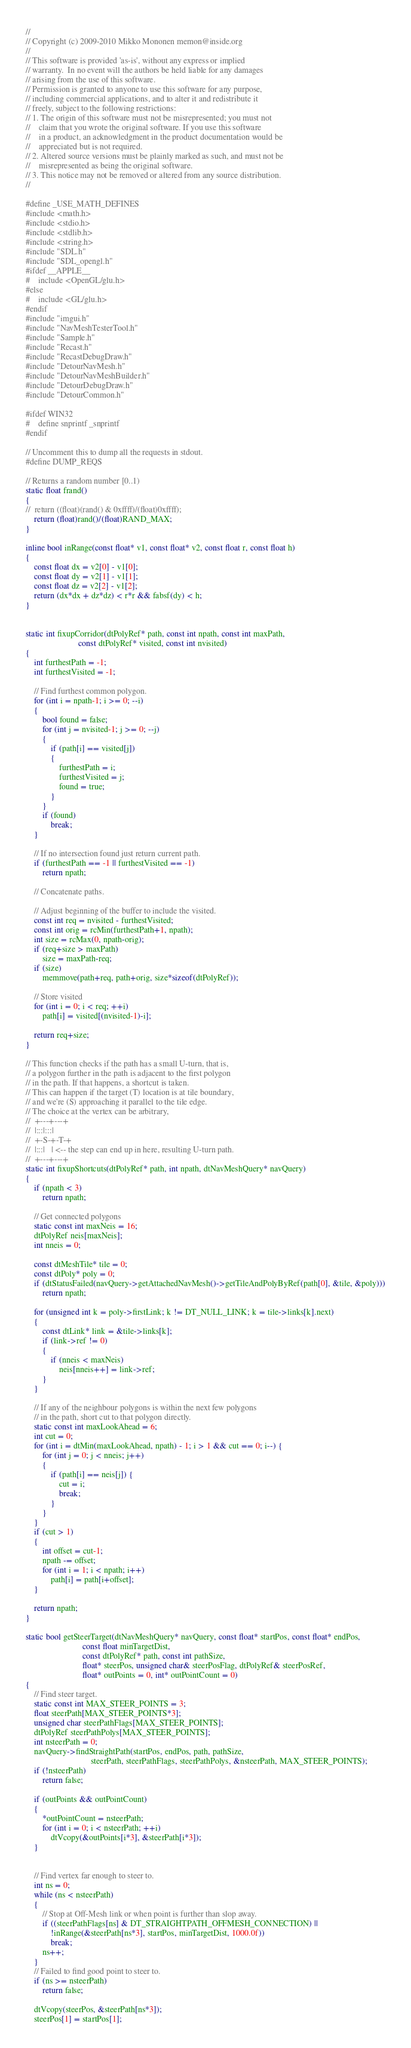Convert code to text. <code><loc_0><loc_0><loc_500><loc_500><_C++_>//
// Copyright (c) 2009-2010 Mikko Mononen memon@inside.org
//
// This software is provided 'as-is', without any express or implied
// warranty.  In no event will the authors be held liable for any damages
// arising from the use of this software.
// Permission is granted to anyone to use this software for any purpose,
// including commercial applications, and to alter it and redistribute it
// freely, subject to the following restrictions:
// 1. The origin of this software must not be misrepresented; you must not
//    claim that you wrote the original software. If you use this software
//    in a product, an acknowledgment in the product documentation would be
//    appreciated but is not required.
// 2. Altered source versions must be plainly marked as such, and must not be
//    misrepresented as being the original software.
// 3. This notice may not be removed or altered from any source distribution.
//

#define _USE_MATH_DEFINES
#include <math.h>
#include <stdio.h>
#include <stdlib.h>
#include <string.h>
#include "SDL.h"
#include "SDL_opengl.h"
#ifdef __APPLE__
#	include <OpenGL/glu.h>
#else
#	include <GL/glu.h>
#endif
#include "imgui.h"
#include "NavMeshTesterTool.h"
#include "Sample.h"
#include "Recast.h"
#include "RecastDebugDraw.h"
#include "DetourNavMesh.h"
#include "DetourNavMeshBuilder.h"
#include "DetourDebugDraw.h"
#include "DetourCommon.h"

#ifdef WIN32
#	define snprintf _snprintf
#endif

// Uncomment this to dump all the requests in stdout.
#define DUMP_REQS

// Returns a random number [0..1)
static float frand()
{
//	return ((float)(rand() & 0xffff)/(float)0xffff);
	return (float)rand()/(float)RAND_MAX;
}

inline bool inRange(const float* v1, const float* v2, const float r, const float h)
{
	const float dx = v2[0] - v1[0];
	const float dy = v2[1] - v1[1];
	const float dz = v2[2] - v1[2];
	return (dx*dx + dz*dz) < r*r && fabsf(dy) < h;
}


static int fixupCorridor(dtPolyRef* path, const int npath, const int maxPath,
						 const dtPolyRef* visited, const int nvisited)
{
	int furthestPath = -1;
	int furthestVisited = -1;
	
	// Find furthest common polygon.
	for (int i = npath-1; i >= 0; --i)
	{
		bool found = false;
		for (int j = nvisited-1; j >= 0; --j)
		{
			if (path[i] == visited[j])
			{
				furthestPath = i;
				furthestVisited = j;
				found = true;
			}
		}
		if (found)
			break;
	}

	// If no intersection found just return current path. 
	if (furthestPath == -1 || furthestVisited == -1)
		return npath;
	
	// Concatenate paths.	

	// Adjust beginning of the buffer to include the visited.
	const int req = nvisited - furthestVisited;
	const int orig = rcMin(furthestPath+1, npath);
	int size = rcMax(0, npath-orig);
	if (req+size > maxPath)
		size = maxPath-req;
	if (size)
		memmove(path+req, path+orig, size*sizeof(dtPolyRef));
	
	// Store visited
	for (int i = 0; i < req; ++i)
		path[i] = visited[(nvisited-1)-i];				
	
	return req+size;
}

// This function checks if the path has a small U-turn, that is,
// a polygon further in the path is adjacent to the first polygon
// in the path. If that happens, a shortcut is taken.
// This can happen if the target (T) location is at tile boundary,
// and we're (S) approaching it parallel to the tile edge.
// The choice at the vertex can be arbitrary, 
//  +---+---+
//  |:::|:::|
//  +-S-+-T-+
//  |:::|   | <-- the step can end up in here, resulting U-turn path.
//  +---+---+
static int fixupShortcuts(dtPolyRef* path, int npath, dtNavMeshQuery* navQuery)
{
	if (npath < 3)
		return npath;

	// Get connected polygons
	static const int maxNeis = 16;
	dtPolyRef neis[maxNeis];
	int nneis = 0;

	const dtMeshTile* tile = 0;
	const dtPoly* poly = 0;
	if (dtStatusFailed(navQuery->getAttachedNavMesh()->getTileAndPolyByRef(path[0], &tile, &poly)))
		return npath;
	
	for (unsigned int k = poly->firstLink; k != DT_NULL_LINK; k = tile->links[k].next)
	{
		const dtLink* link = &tile->links[k];
		if (link->ref != 0)
		{
			if (nneis < maxNeis)
				neis[nneis++] = link->ref;
		}
	}

	// If any of the neighbour polygons is within the next few polygons
	// in the path, short cut to that polygon directly.
	static const int maxLookAhead = 6;
	int cut = 0;
	for (int i = dtMin(maxLookAhead, npath) - 1; i > 1 && cut == 0; i--) {
		for (int j = 0; j < nneis; j++)
		{
			if (path[i] == neis[j]) {
				cut = i;
				break;
			}
		}
	}
	if (cut > 1)
	{
		int offset = cut-1;
		npath -= offset;
		for (int i = 1; i < npath; i++)
			path[i] = path[i+offset];
	}

	return npath;
}

static bool getSteerTarget(dtNavMeshQuery* navQuery, const float* startPos, const float* endPos,
						   const float minTargetDist,
						   const dtPolyRef* path, const int pathSize,
						   float* steerPos, unsigned char& steerPosFlag, dtPolyRef& steerPosRef,
						   float* outPoints = 0, int* outPointCount = 0)							 
{
	// Find steer target.
	static const int MAX_STEER_POINTS = 3;
	float steerPath[MAX_STEER_POINTS*3];
	unsigned char steerPathFlags[MAX_STEER_POINTS];
	dtPolyRef steerPathPolys[MAX_STEER_POINTS];
	int nsteerPath = 0;
	navQuery->findStraightPath(startPos, endPos, path, pathSize,
							   steerPath, steerPathFlags, steerPathPolys, &nsteerPath, MAX_STEER_POINTS);
	if (!nsteerPath)
		return false;
		
	if (outPoints && outPointCount)
	{
		*outPointCount = nsteerPath;
		for (int i = 0; i < nsteerPath; ++i)
			dtVcopy(&outPoints[i*3], &steerPath[i*3]);
	}

	
	// Find vertex far enough to steer to.
	int ns = 0;
	while (ns < nsteerPath)
	{
		// Stop at Off-Mesh link or when point is further than slop away.
		if ((steerPathFlags[ns] & DT_STRAIGHTPATH_OFFMESH_CONNECTION) ||
			!inRange(&steerPath[ns*3], startPos, minTargetDist, 1000.0f))
			break;
		ns++;
	}
	// Failed to find good point to steer to.
	if (ns >= nsteerPath)
		return false;
	
	dtVcopy(steerPos, &steerPath[ns*3]);
	steerPos[1] = startPos[1];</code> 